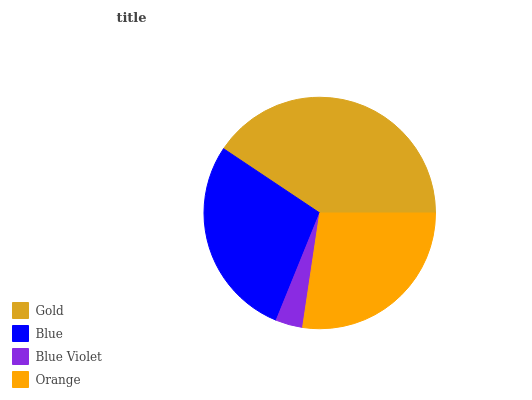Is Blue Violet the minimum?
Answer yes or no. Yes. Is Gold the maximum?
Answer yes or no. Yes. Is Blue the minimum?
Answer yes or no. No. Is Blue the maximum?
Answer yes or no. No. Is Gold greater than Blue?
Answer yes or no. Yes. Is Blue less than Gold?
Answer yes or no. Yes. Is Blue greater than Gold?
Answer yes or no. No. Is Gold less than Blue?
Answer yes or no. No. Is Blue the high median?
Answer yes or no. Yes. Is Orange the low median?
Answer yes or no. Yes. Is Blue Violet the high median?
Answer yes or no. No. Is Blue the low median?
Answer yes or no. No. 